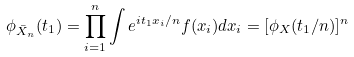<formula> <loc_0><loc_0><loc_500><loc_500>\phi _ { \bar { X } _ { n } } ( t _ { 1 } ) = \prod _ { i = 1 } ^ { n } \int e ^ { i t _ { 1 } x _ { i } / n } f ( x _ { i } ) d x _ { i } = [ \phi _ { X } ( t _ { 1 } / n ) ] ^ { n }</formula> 